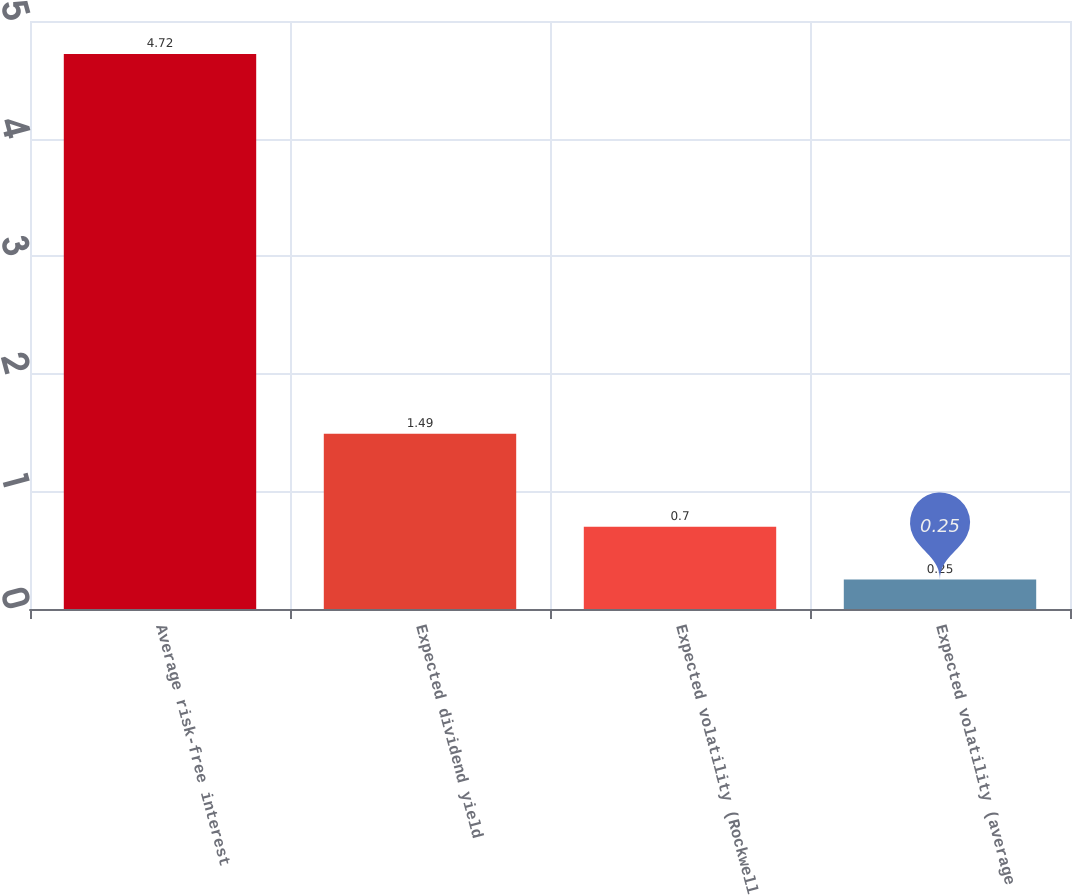<chart> <loc_0><loc_0><loc_500><loc_500><bar_chart><fcel>Average risk-free interest<fcel>Expected dividend yield<fcel>Expected volatility (Rockwell<fcel>Expected volatility (average<nl><fcel>4.72<fcel>1.49<fcel>0.7<fcel>0.25<nl></chart> 